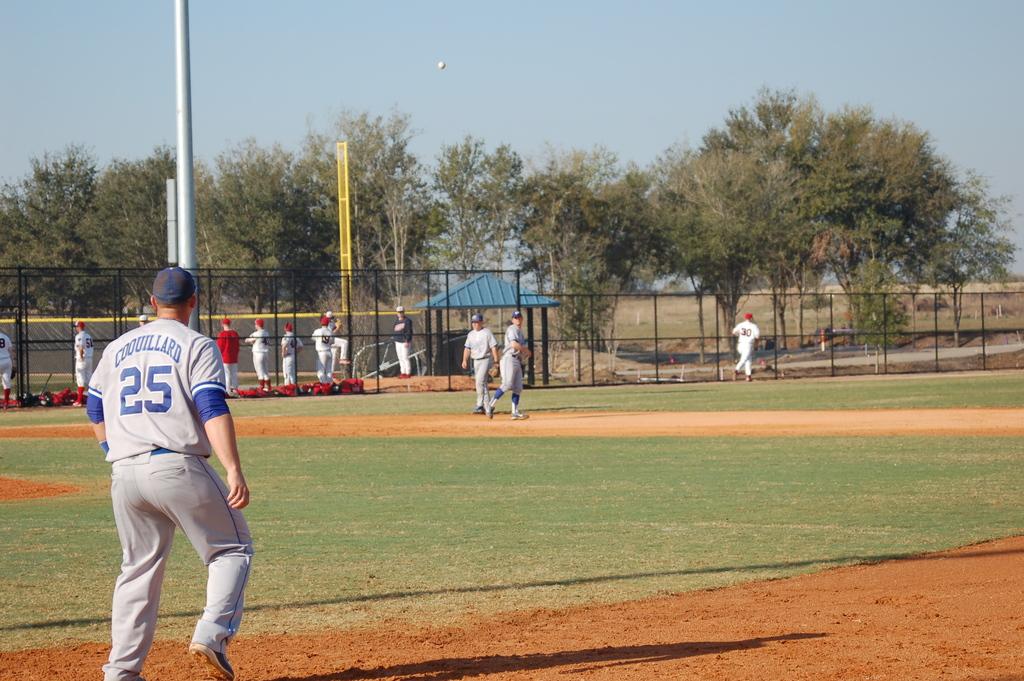What is the name of number 25?
Your answer should be compact. Coquillard. What number is the outfielder?
Provide a succinct answer. 25. 